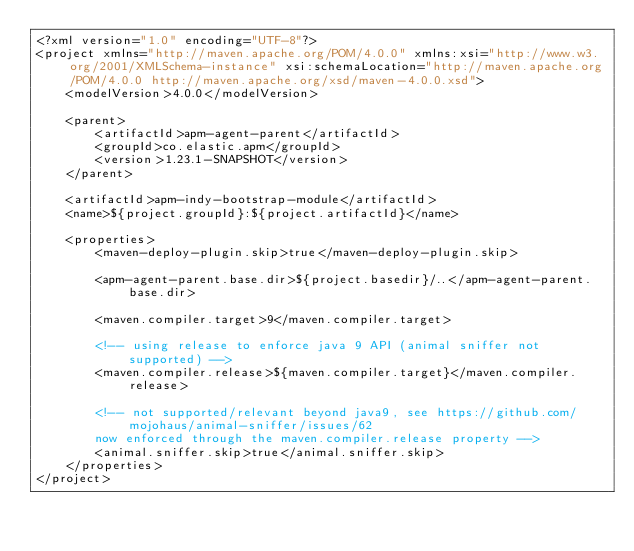<code> <loc_0><loc_0><loc_500><loc_500><_XML_><?xml version="1.0" encoding="UTF-8"?>
<project xmlns="http://maven.apache.org/POM/4.0.0" xmlns:xsi="http://www.w3.org/2001/XMLSchema-instance" xsi:schemaLocation="http://maven.apache.org/POM/4.0.0 http://maven.apache.org/xsd/maven-4.0.0.xsd">
    <modelVersion>4.0.0</modelVersion>

    <parent>
        <artifactId>apm-agent-parent</artifactId>
        <groupId>co.elastic.apm</groupId>
        <version>1.23.1-SNAPSHOT</version>
    </parent>

    <artifactId>apm-indy-bootstrap-module</artifactId>
    <name>${project.groupId}:${project.artifactId}</name>

    <properties>
        <maven-deploy-plugin.skip>true</maven-deploy-plugin.skip>

        <apm-agent-parent.base.dir>${project.basedir}/..</apm-agent-parent.base.dir>

        <maven.compiler.target>9</maven.compiler.target>

        <!-- using release to enforce java 9 API (animal sniffer not supported) -->
        <maven.compiler.release>${maven.compiler.target}</maven.compiler.release>

        <!-- not supported/relevant beyond java9, see https://github.com/mojohaus/animal-sniffer/issues/62
        now enforced through the maven.compiler.release property -->
        <animal.sniffer.skip>true</animal.sniffer.skip>
    </properties>
</project>
</code> 